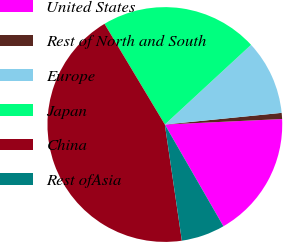Convert chart. <chart><loc_0><loc_0><loc_500><loc_500><pie_chart><fcel>United States<fcel>Rest of North and South<fcel>Europe<fcel>Japan<fcel>China<fcel>Rest ofAsia<nl><fcel>17.43%<fcel>0.84%<fcel>10.29%<fcel>21.72%<fcel>43.72%<fcel>6.0%<nl></chart> 